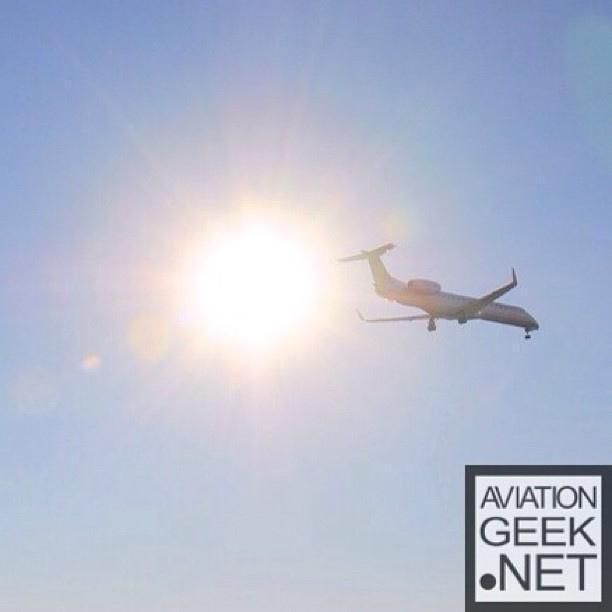How many airplanes can you see?
Give a very brief answer. 1. 